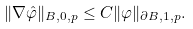Convert formula to latex. <formula><loc_0><loc_0><loc_500><loc_500>\| \nabla \hat { \varphi } \| _ { B , 0 , p } \leq C \| \varphi \| _ { \partial B , 1 , p } .</formula> 